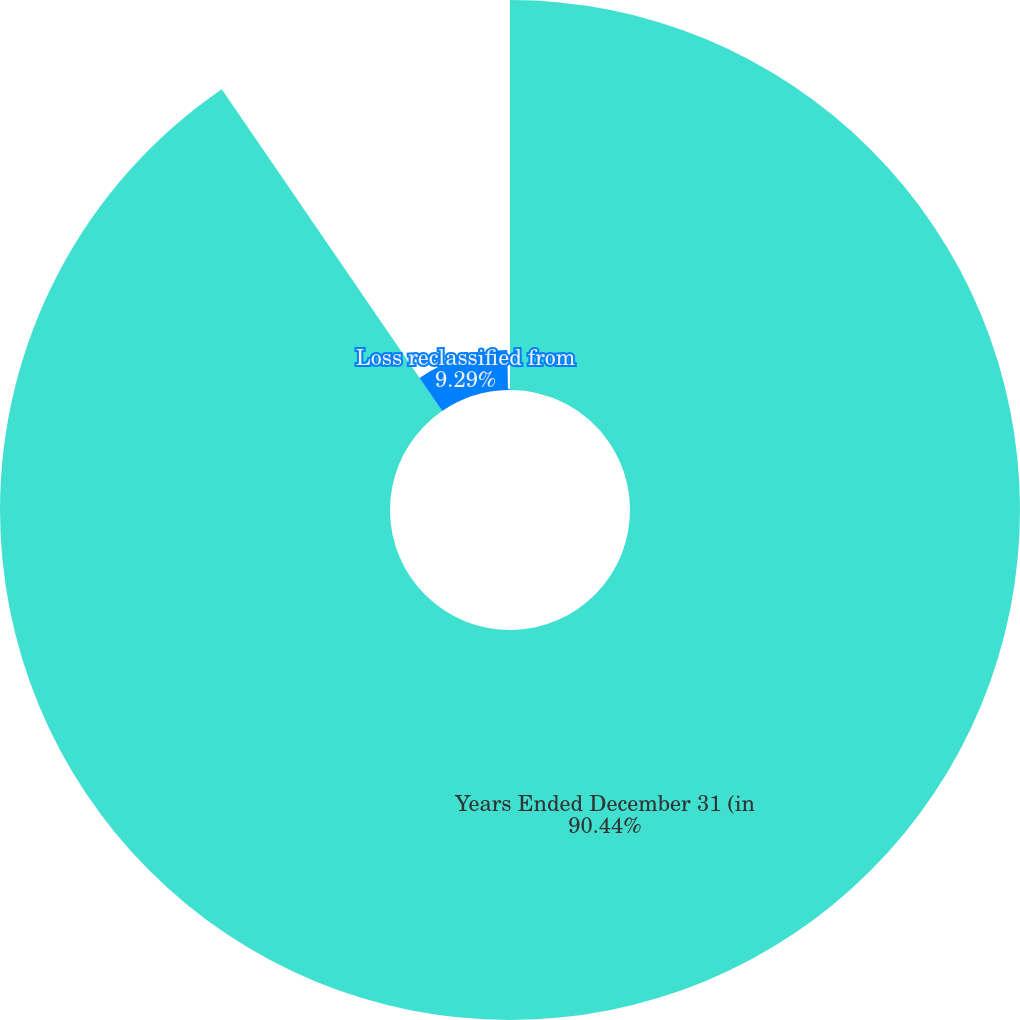<chart> <loc_0><loc_0><loc_500><loc_500><pie_chart><fcel>Years Ended December 31 (in<fcel>Loss reclassified from<fcel>Gain (loss) recognized in<nl><fcel>90.44%<fcel>9.29%<fcel>0.27%<nl></chart> 